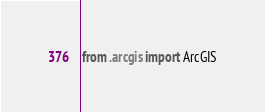<code> <loc_0><loc_0><loc_500><loc_500><_Python_>from .arcgis import ArcGIS</code> 